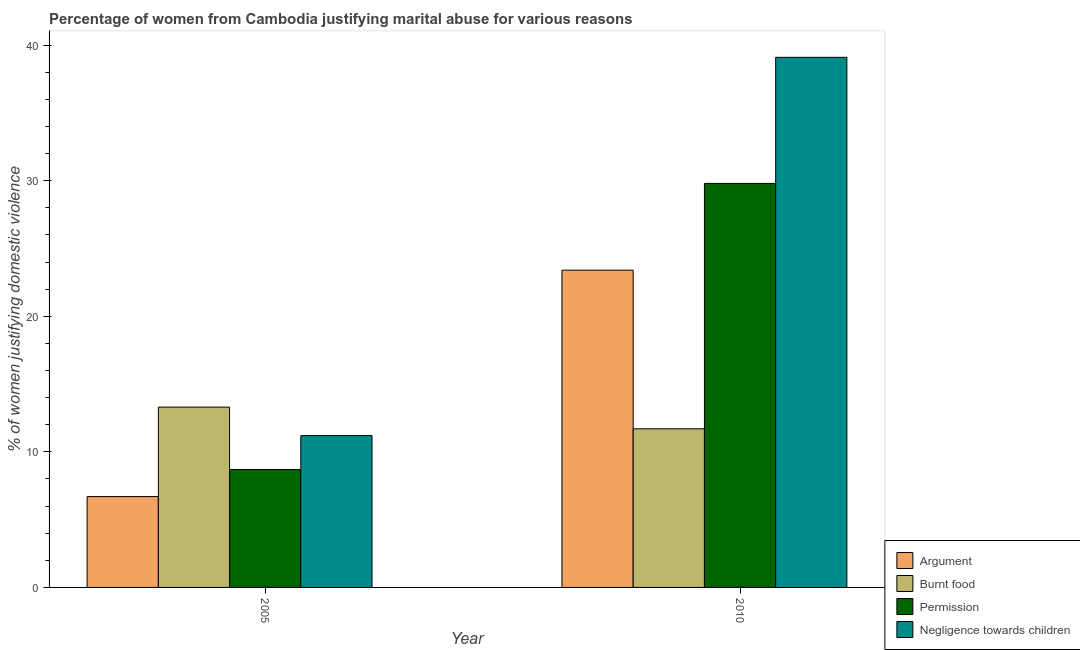How many bars are there on the 1st tick from the right?
Your answer should be very brief. 4. What is the label of the 1st group of bars from the left?
Offer a terse response. 2005. What is the percentage of women justifying abuse for burning food in 2005?
Provide a succinct answer. 13.3. Across all years, what is the maximum percentage of women justifying abuse in the case of an argument?
Your answer should be compact. 23.4. In which year was the percentage of women justifying abuse for burning food maximum?
Offer a terse response. 2005. In which year was the percentage of women justifying abuse for going without permission minimum?
Provide a short and direct response. 2005. What is the total percentage of women justifying abuse for showing negligence towards children in the graph?
Your answer should be very brief. 50.3. What is the difference between the percentage of women justifying abuse for going without permission in 2005 and that in 2010?
Your answer should be very brief. -21.1. What is the difference between the percentage of women justifying abuse in the case of an argument in 2005 and the percentage of women justifying abuse for burning food in 2010?
Keep it short and to the point. -16.7. What is the average percentage of women justifying abuse for burning food per year?
Make the answer very short. 12.5. In the year 2005, what is the difference between the percentage of women justifying abuse for burning food and percentage of women justifying abuse for showing negligence towards children?
Offer a terse response. 0. What is the ratio of the percentage of women justifying abuse for showing negligence towards children in 2005 to that in 2010?
Provide a succinct answer. 0.29. In how many years, is the percentage of women justifying abuse for burning food greater than the average percentage of women justifying abuse for burning food taken over all years?
Your answer should be compact. 1. What does the 3rd bar from the left in 2005 represents?
Your answer should be compact. Permission. What does the 4th bar from the right in 2005 represents?
Ensure brevity in your answer.  Argument. Is it the case that in every year, the sum of the percentage of women justifying abuse in the case of an argument and percentage of women justifying abuse for burning food is greater than the percentage of women justifying abuse for going without permission?
Your answer should be compact. Yes. How many bars are there?
Keep it short and to the point. 8. How many years are there in the graph?
Keep it short and to the point. 2. What is the difference between two consecutive major ticks on the Y-axis?
Offer a very short reply. 10. Are the values on the major ticks of Y-axis written in scientific E-notation?
Make the answer very short. No. Does the graph contain any zero values?
Make the answer very short. No. Does the graph contain grids?
Your response must be concise. No. How are the legend labels stacked?
Your response must be concise. Vertical. What is the title of the graph?
Your response must be concise. Percentage of women from Cambodia justifying marital abuse for various reasons. Does "Manufacturing" appear as one of the legend labels in the graph?
Offer a terse response. No. What is the label or title of the Y-axis?
Offer a very short reply. % of women justifying domestic violence. What is the % of women justifying domestic violence of Argument in 2005?
Ensure brevity in your answer.  6.7. What is the % of women justifying domestic violence in Permission in 2005?
Provide a short and direct response. 8.7. What is the % of women justifying domestic violence of Negligence towards children in 2005?
Offer a very short reply. 11.2. What is the % of women justifying domestic violence of Argument in 2010?
Your response must be concise. 23.4. What is the % of women justifying domestic violence in Burnt food in 2010?
Make the answer very short. 11.7. What is the % of women justifying domestic violence of Permission in 2010?
Provide a short and direct response. 29.8. What is the % of women justifying domestic violence of Negligence towards children in 2010?
Keep it short and to the point. 39.1. Across all years, what is the maximum % of women justifying domestic violence of Argument?
Your answer should be compact. 23.4. Across all years, what is the maximum % of women justifying domestic violence of Burnt food?
Give a very brief answer. 13.3. Across all years, what is the maximum % of women justifying domestic violence of Permission?
Offer a terse response. 29.8. Across all years, what is the maximum % of women justifying domestic violence in Negligence towards children?
Provide a short and direct response. 39.1. Across all years, what is the minimum % of women justifying domestic violence of Permission?
Make the answer very short. 8.7. Across all years, what is the minimum % of women justifying domestic violence in Negligence towards children?
Provide a short and direct response. 11.2. What is the total % of women justifying domestic violence of Argument in the graph?
Provide a succinct answer. 30.1. What is the total % of women justifying domestic violence in Burnt food in the graph?
Your response must be concise. 25. What is the total % of women justifying domestic violence of Permission in the graph?
Offer a terse response. 38.5. What is the total % of women justifying domestic violence in Negligence towards children in the graph?
Keep it short and to the point. 50.3. What is the difference between the % of women justifying domestic violence of Argument in 2005 and that in 2010?
Offer a terse response. -16.7. What is the difference between the % of women justifying domestic violence in Permission in 2005 and that in 2010?
Your response must be concise. -21.1. What is the difference between the % of women justifying domestic violence of Negligence towards children in 2005 and that in 2010?
Your answer should be compact. -27.9. What is the difference between the % of women justifying domestic violence of Argument in 2005 and the % of women justifying domestic violence of Permission in 2010?
Give a very brief answer. -23.1. What is the difference between the % of women justifying domestic violence in Argument in 2005 and the % of women justifying domestic violence in Negligence towards children in 2010?
Provide a short and direct response. -32.4. What is the difference between the % of women justifying domestic violence of Burnt food in 2005 and the % of women justifying domestic violence of Permission in 2010?
Make the answer very short. -16.5. What is the difference between the % of women justifying domestic violence in Burnt food in 2005 and the % of women justifying domestic violence in Negligence towards children in 2010?
Provide a succinct answer. -25.8. What is the difference between the % of women justifying domestic violence of Permission in 2005 and the % of women justifying domestic violence of Negligence towards children in 2010?
Your answer should be very brief. -30.4. What is the average % of women justifying domestic violence of Argument per year?
Provide a short and direct response. 15.05. What is the average % of women justifying domestic violence in Permission per year?
Your answer should be compact. 19.25. What is the average % of women justifying domestic violence of Negligence towards children per year?
Provide a short and direct response. 25.15. In the year 2005, what is the difference between the % of women justifying domestic violence in Argument and % of women justifying domestic violence in Burnt food?
Ensure brevity in your answer.  -6.6. In the year 2005, what is the difference between the % of women justifying domestic violence of Argument and % of women justifying domestic violence of Permission?
Your answer should be very brief. -2. In the year 2010, what is the difference between the % of women justifying domestic violence of Argument and % of women justifying domestic violence of Burnt food?
Ensure brevity in your answer.  11.7. In the year 2010, what is the difference between the % of women justifying domestic violence of Argument and % of women justifying domestic violence of Permission?
Your answer should be very brief. -6.4. In the year 2010, what is the difference between the % of women justifying domestic violence in Argument and % of women justifying domestic violence in Negligence towards children?
Give a very brief answer. -15.7. In the year 2010, what is the difference between the % of women justifying domestic violence in Burnt food and % of women justifying domestic violence in Permission?
Make the answer very short. -18.1. In the year 2010, what is the difference between the % of women justifying domestic violence in Burnt food and % of women justifying domestic violence in Negligence towards children?
Provide a succinct answer. -27.4. What is the ratio of the % of women justifying domestic violence in Argument in 2005 to that in 2010?
Ensure brevity in your answer.  0.29. What is the ratio of the % of women justifying domestic violence in Burnt food in 2005 to that in 2010?
Offer a very short reply. 1.14. What is the ratio of the % of women justifying domestic violence of Permission in 2005 to that in 2010?
Your answer should be compact. 0.29. What is the ratio of the % of women justifying domestic violence in Negligence towards children in 2005 to that in 2010?
Provide a short and direct response. 0.29. What is the difference between the highest and the second highest % of women justifying domestic violence in Burnt food?
Give a very brief answer. 1.6. What is the difference between the highest and the second highest % of women justifying domestic violence of Permission?
Keep it short and to the point. 21.1. What is the difference between the highest and the second highest % of women justifying domestic violence in Negligence towards children?
Provide a succinct answer. 27.9. What is the difference between the highest and the lowest % of women justifying domestic violence of Argument?
Make the answer very short. 16.7. What is the difference between the highest and the lowest % of women justifying domestic violence of Permission?
Offer a very short reply. 21.1. What is the difference between the highest and the lowest % of women justifying domestic violence in Negligence towards children?
Offer a very short reply. 27.9. 